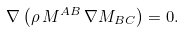<formula> <loc_0><loc_0><loc_500><loc_500>\nabla \left ( \rho \, M ^ { A B } \, \nabla M _ { B C } \right ) = 0 .</formula> 